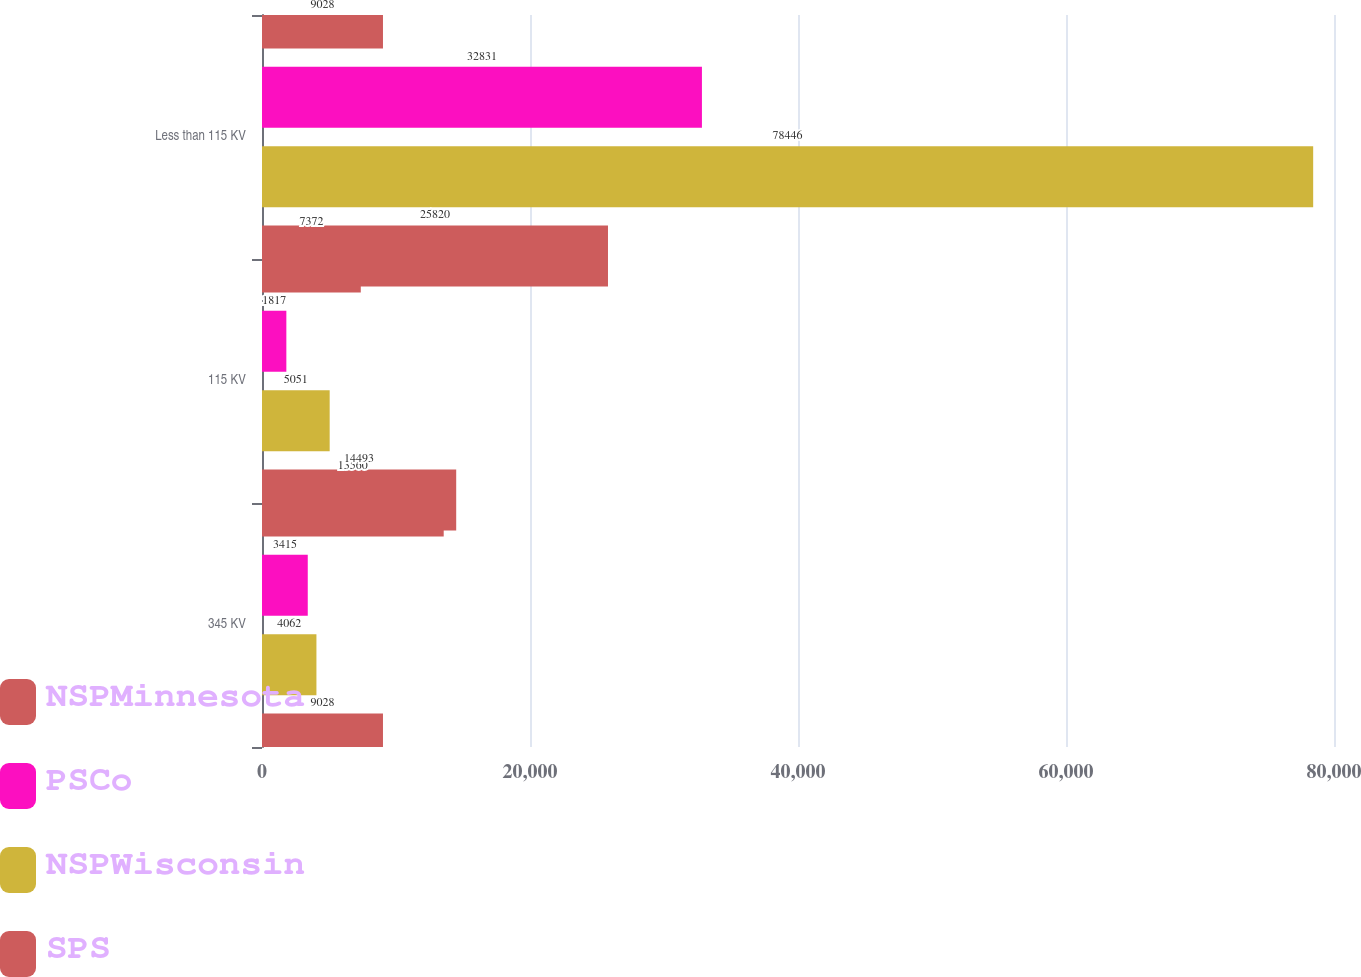Convert chart. <chart><loc_0><loc_0><loc_500><loc_500><stacked_bar_chart><ecel><fcel>345 KV<fcel>115 KV<fcel>Less than 115 KV<nl><fcel>NSPMinnesota<fcel>13560<fcel>7372<fcel>9028<nl><fcel>PSCo<fcel>3415<fcel>1817<fcel>32831<nl><fcel>NSPWisconsin<fcel>4062<fcel>5051<fcel>78446<nl><fcel>SPS<fcel>9028<fcel>14493<fcel>25820<nl></chart> 